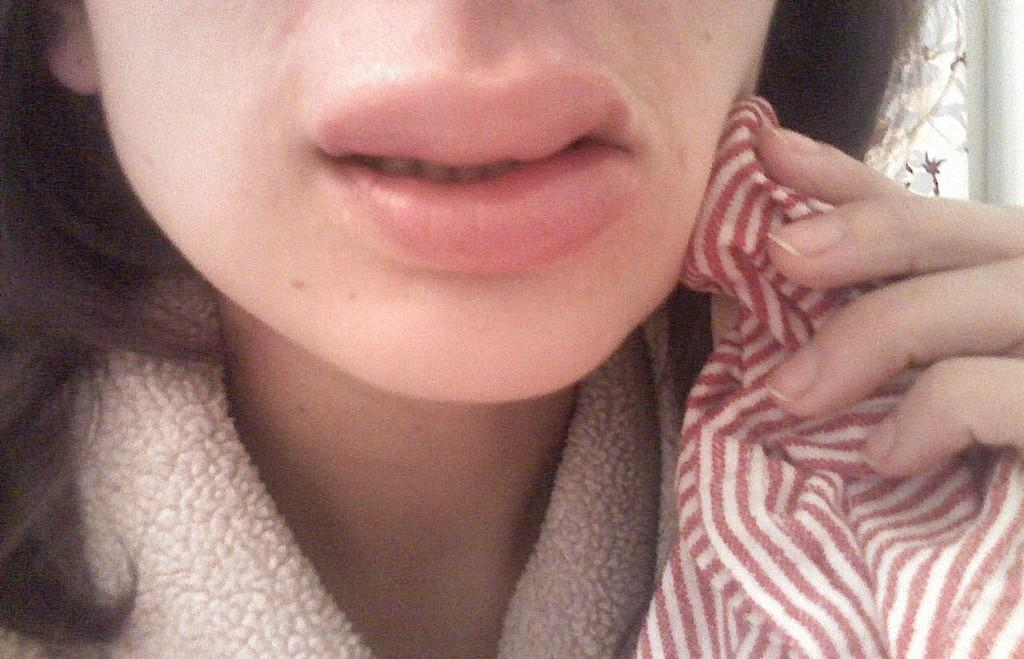Who is the main subject in the image? There is a girl in the image. What part of the girl's face is visible in the image? The girl's lips are visible in the image. What type of material is present in the image? There is cloth in the image. How many giants can be seen interacting with the girl in the image? There are no giants present in the image; it only features a girl and cloth. What is the steepness of the slope in the image? There is no slope present in the image. 